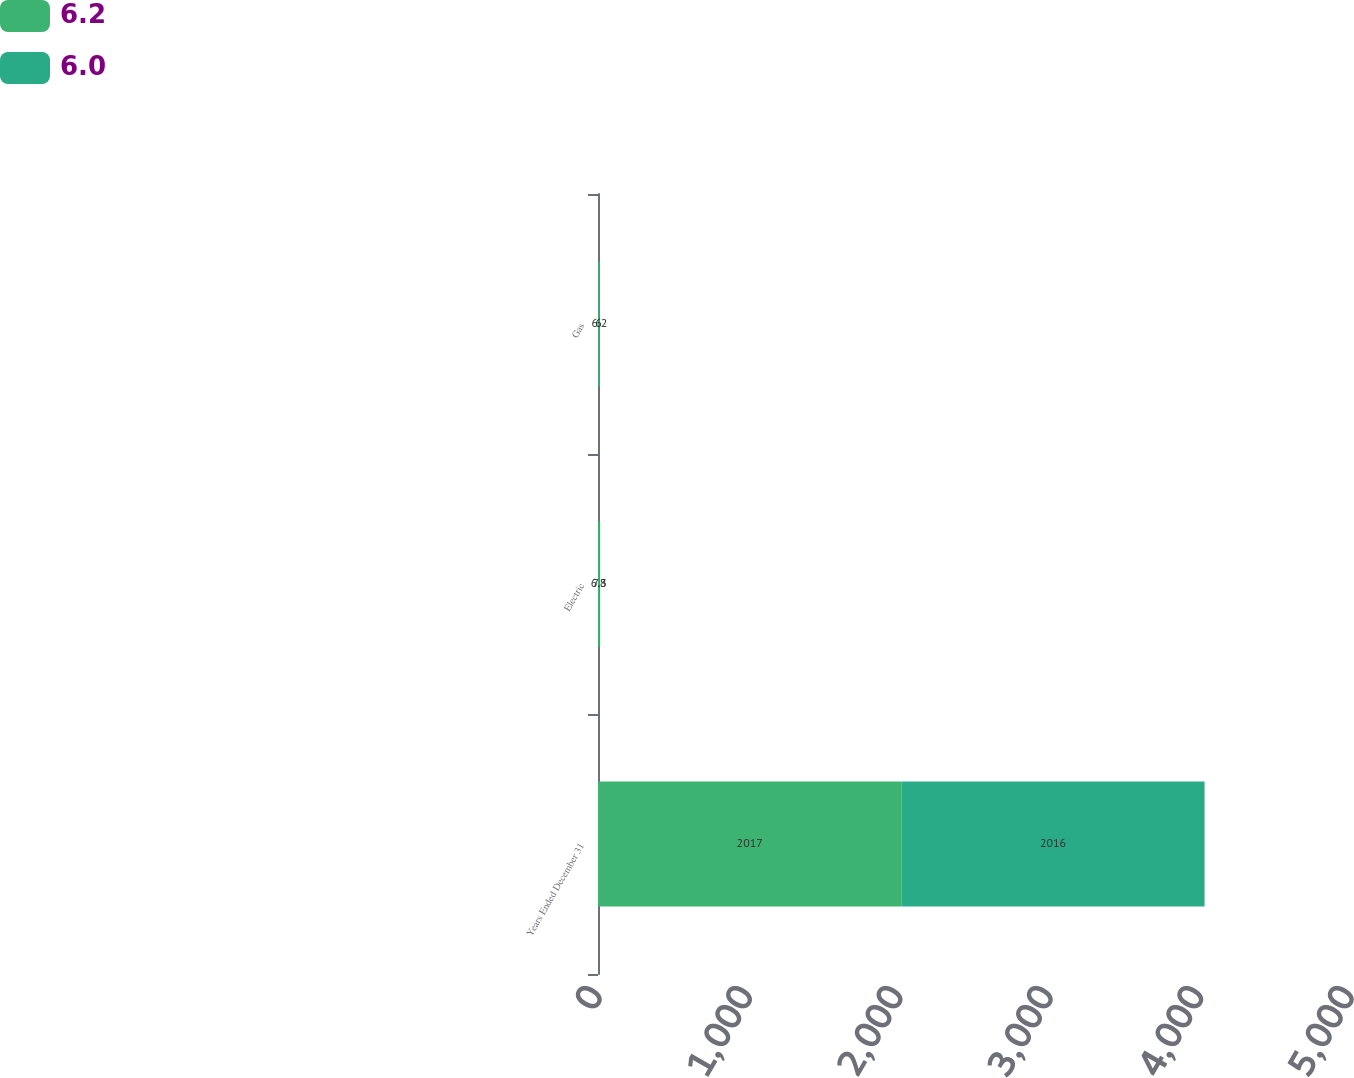Convert chart. <chart><loc_0><loc_0><loc_500><loc_500><stacked_bar_chart><ecel><fcel>Years Ended December 31<fcel>Electric<fcel>Gas<nl><fcel>6.2<fcel>2017<fcel>6.8<fcel>6<nl><fcel>6<fcel>2016<fcel>7.3<fcel>6.2<nl></chart> 